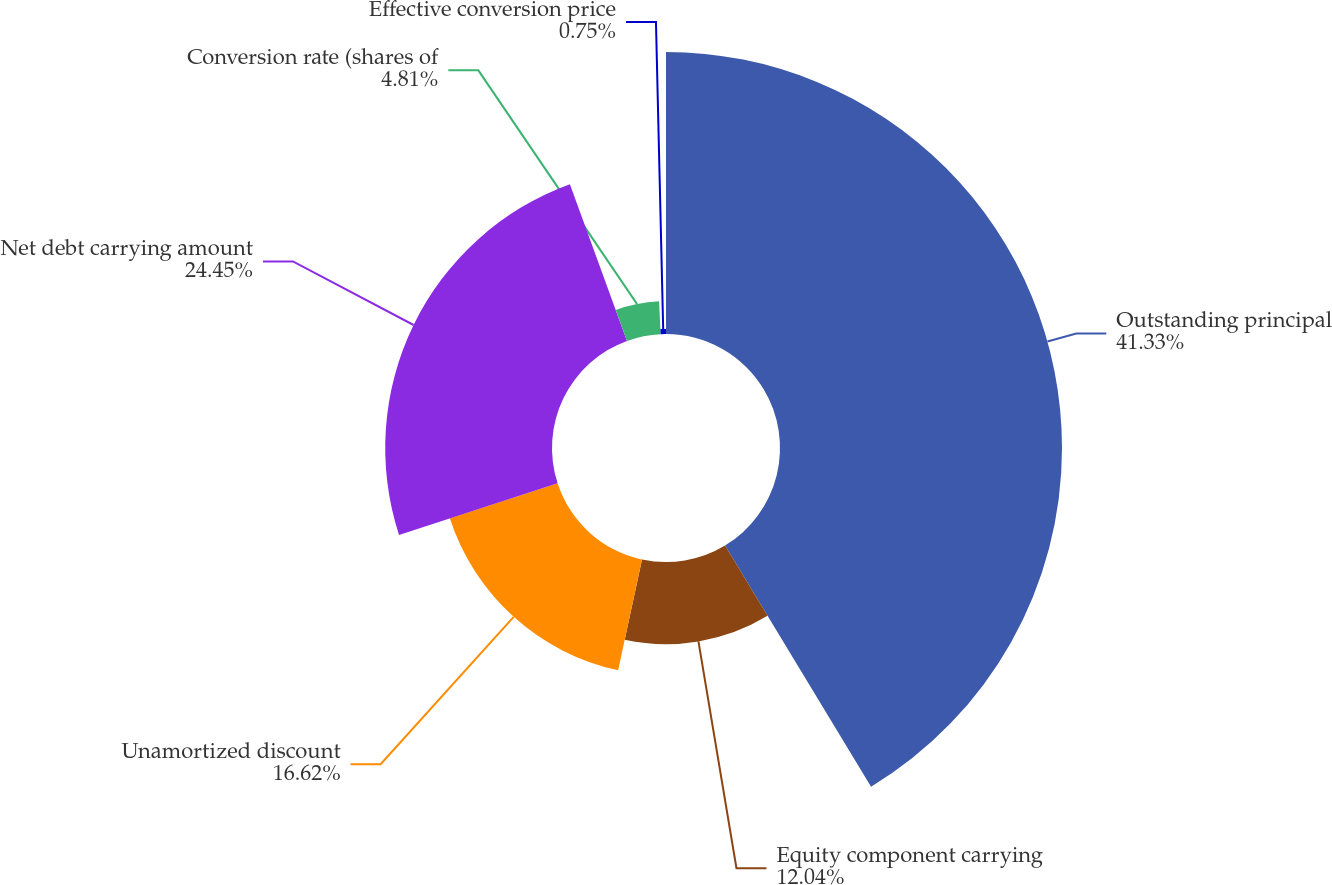Convert chart. <chart><loc_0><loc_0><loc_500><loc_500><pie_chart><fcel>Outstanding principal<fcel>Equity component carrying<fcel>Unamortized discount<fcel>Net debt carrying amount<fcel>Conversion rate (shares of<fcel>Effective conversion price<nl><fcel>41.34%<fcel>12.04%<fcel>16.62%<fcel>24.45%<fcel>4.81%<fcel>0.75%<nl></chart> 